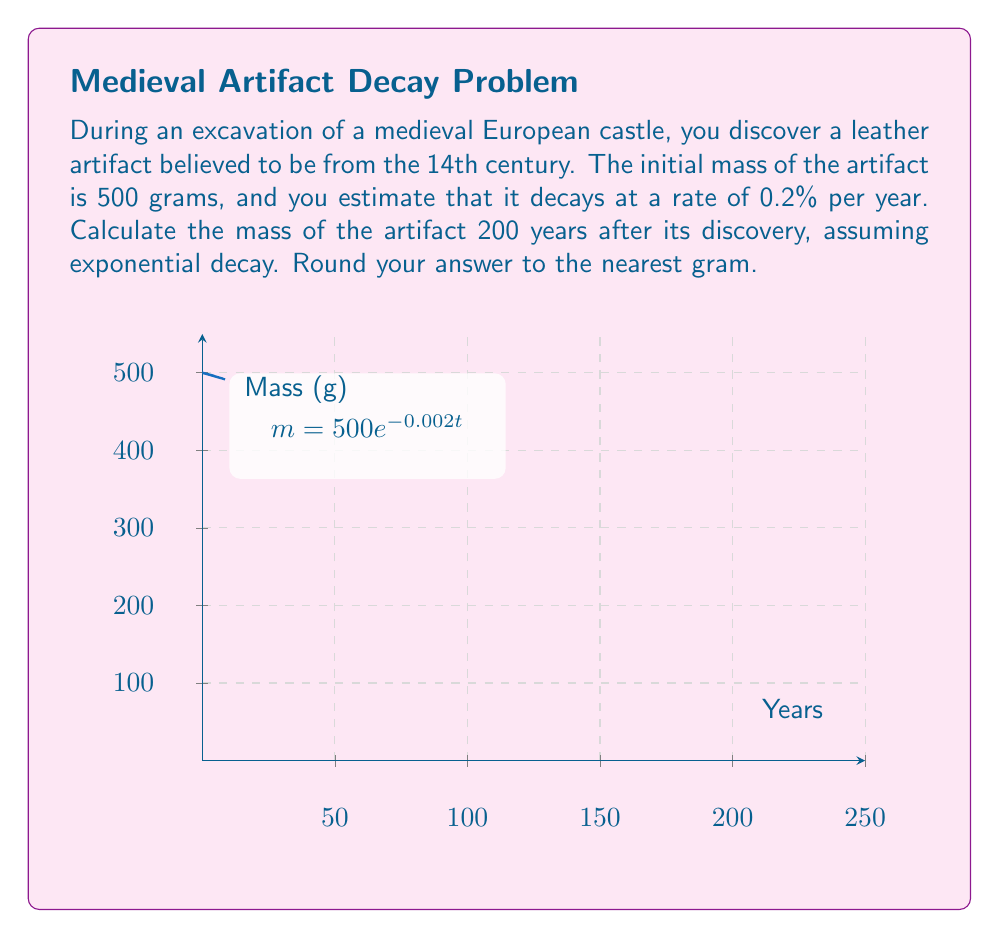What is the answer to this math problem? To solve this problem, we'll use the exponential decay function:

$$ m(t) = m_0 e^{-kt} $$

Where:
- $m(t)$ is the mass at time $t$
- $m_0$ is the initial mass
- $k$ is the decay rate
- $t$ is the time

Given:
- Initial mass $m_0 = 500$ grams
- Decay rate = 0.2% per year = 0.002 (as a decimal)
- Time $t = 200$ years

Step 1: Substitute the values into the exponential decay function:
$$ m(200) = 500 e^{-0.002 \times 200} $$

Step 2: Simplify the exponent:
$$ m(200) = 500 e^{-0.4} $$

Step 3: Calculate the result using a calculator:
$$ m(200) = 500 \times 0.67032 = 335.16 $$

Step 4: Round to the nearest gram:
$$ m(200) \approx 335 \text{ grams} $$

Therefore, after 200 years, the artifact will have a mass of approximately 335 grams.
Answer: 335 grams 